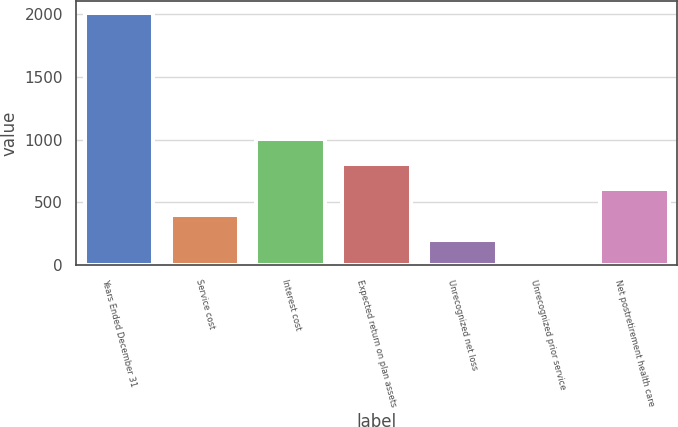Convert chart to OTSL. <chart><loc_0><loc_0><loc_500><loc_500><bar_chart><fcel>Years Ended December 31<fcel>Service cost<fcel>Interest cost<fcel>Expected return on plan assets<fcel>Unrecognized net loss<fcel>Unrecognized prior service<fcel>Net postretirement health care<nl><fcel>2007<fcel>403<fcel>1004.5<fcel>804<fcel>202.5<fcel>2<fcel>603.5<nl></chart> 